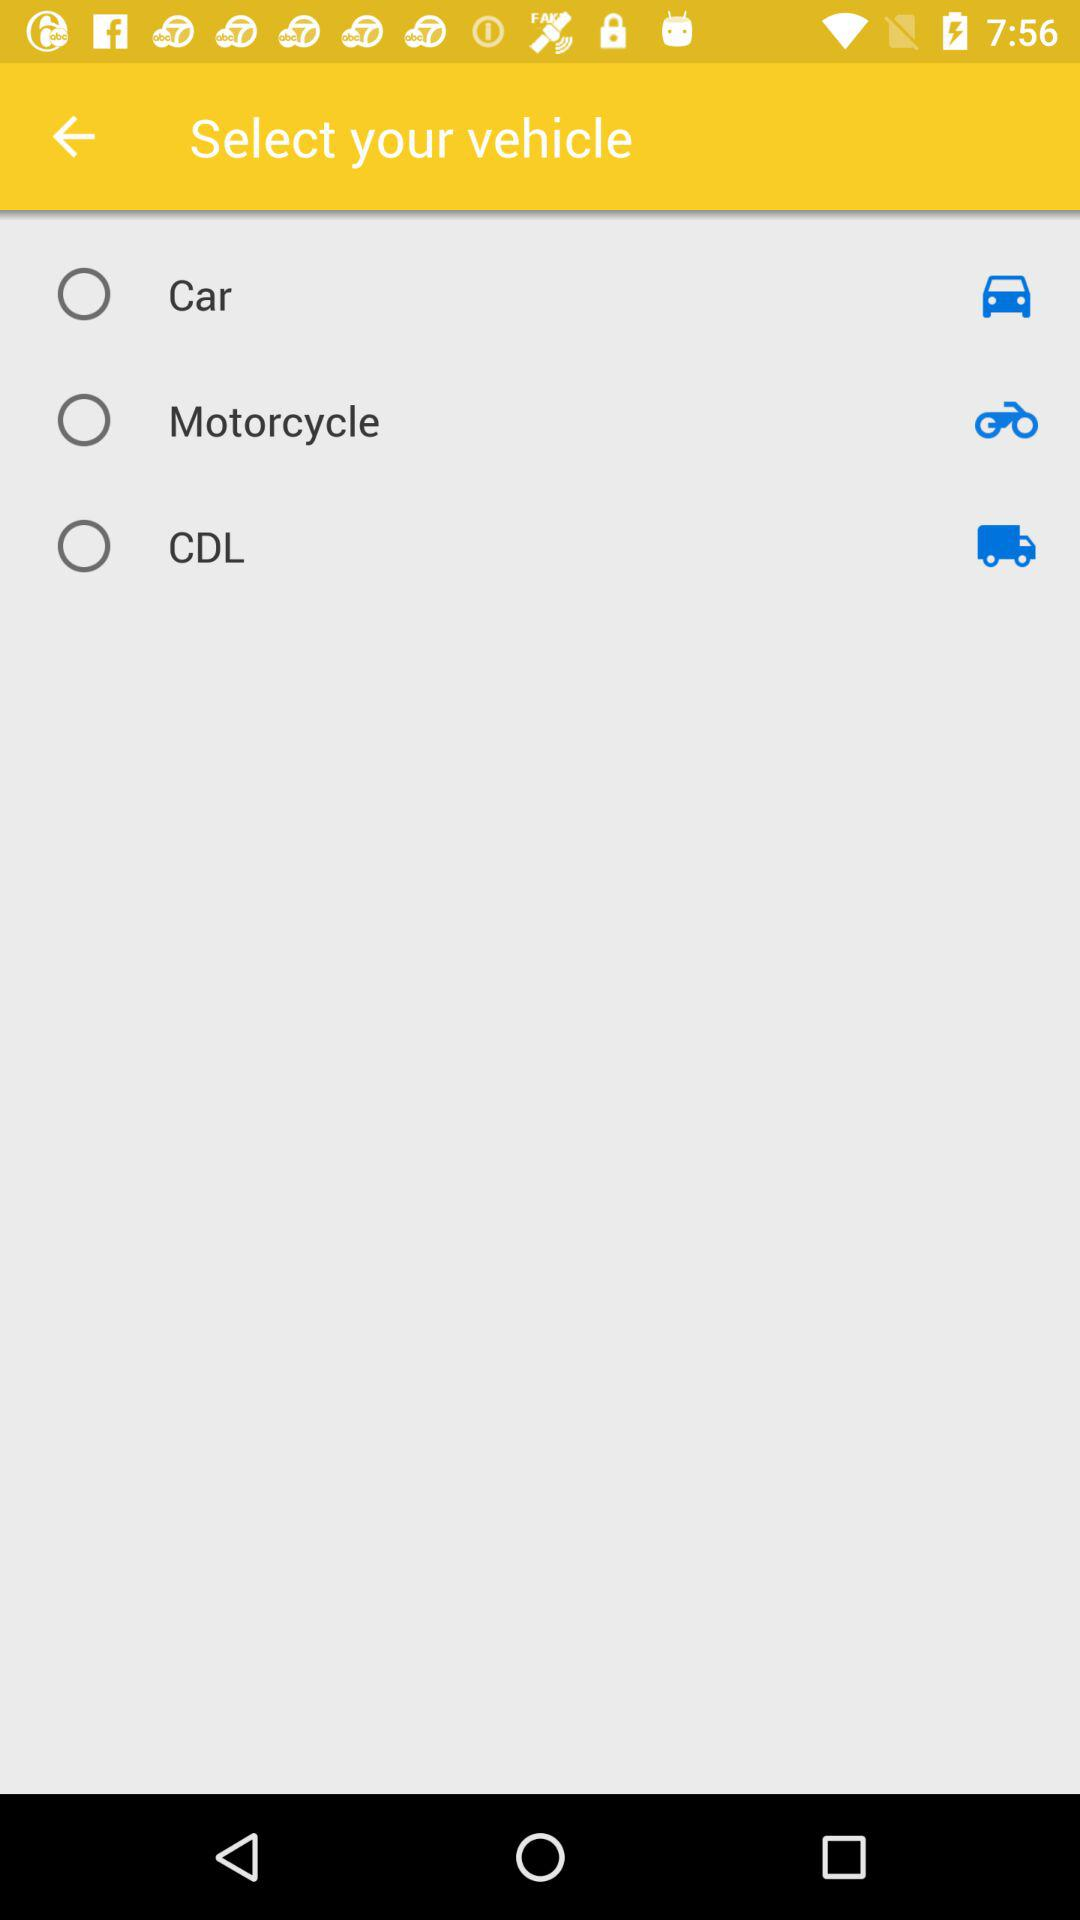How many vehicles can I choose from?
Answer the question using a single word or phrase. 3 